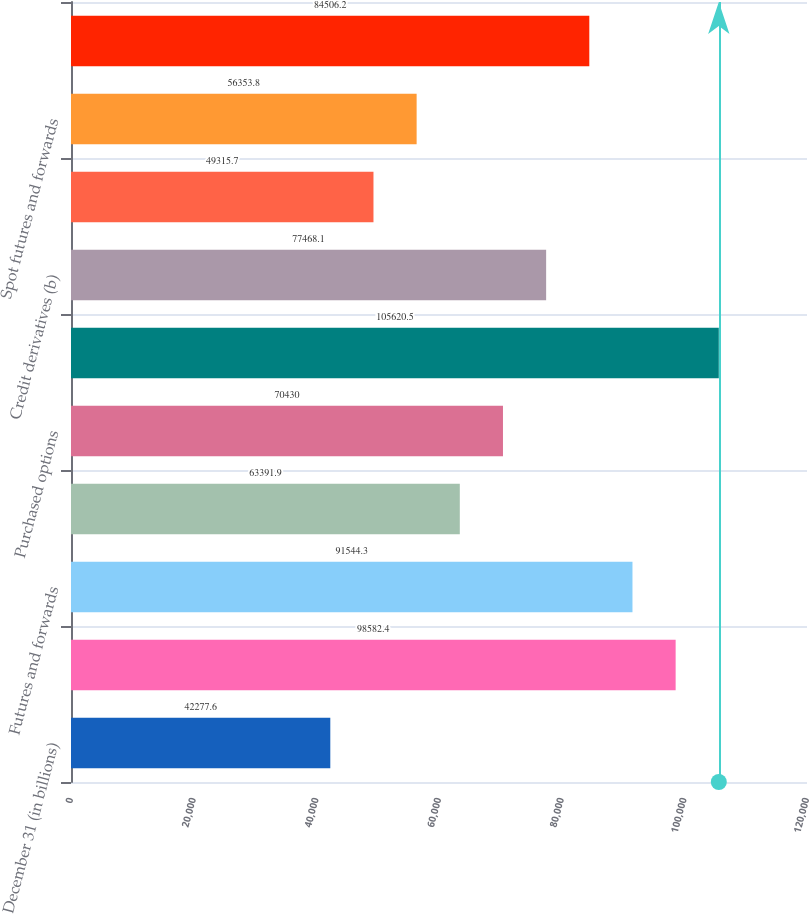Convert chart to OTSL. <chart><loc_0><loc_0><loc_500><loc_500><bar_chart><fcel>December 31 (in billions)<fcel>Swaps<fcel>Futures and forwards<fcel>Written options<fcel>Purchased options<fcel>Total interest rate contracts<fcel>Credit derivatives (b)<fcel>Cross-currency swaps<fcel>Spot futures and forwards<fcel>Total foreign exchange<nl><fcel>42277.6<fcel>98582.4<fcel>91544.3<fcel>63391.9<fcel>70430<fcel>105620<fcel>77468.1<fcel>49315.7<fcel>56353.8<fcel>84506.2<nl></chart> 